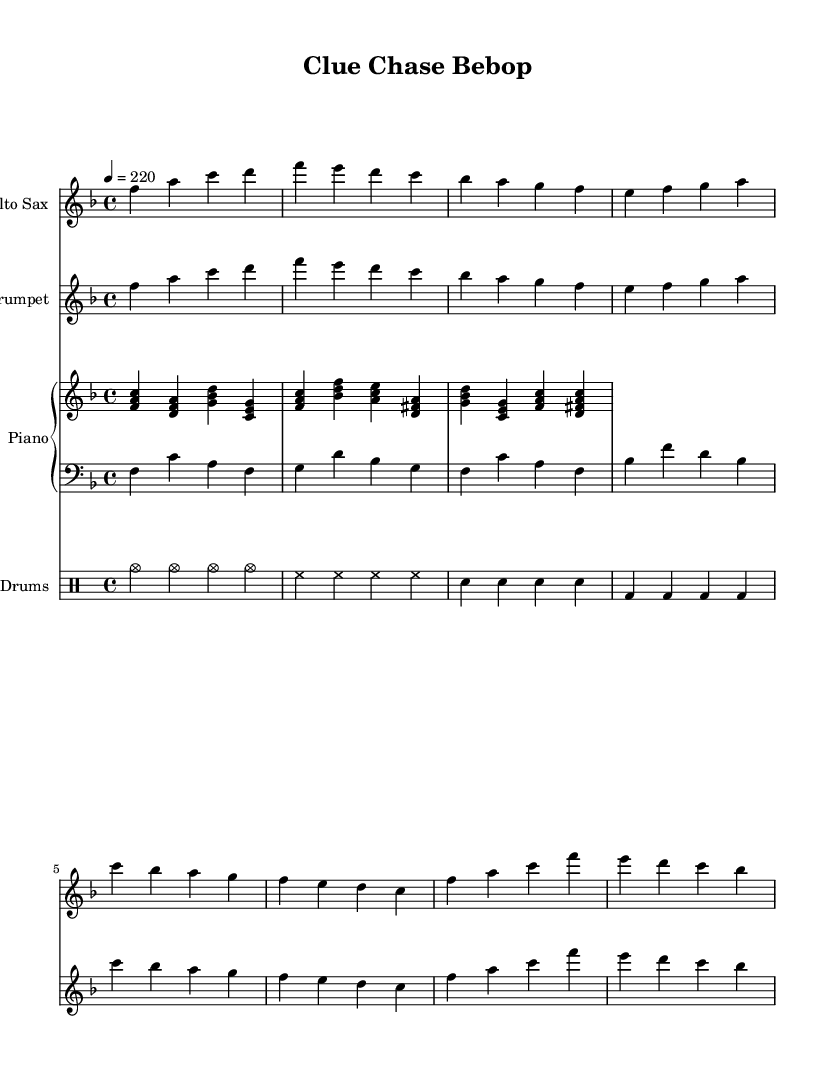What is the key signature of this music? The key signature indicates F major, which has one flat (B flat). This is visible at the beginning of the sheet music where the key signature is marked.
Answer: F major What is the time signature of this music? The time signature shown at the beginning of the sheet music is 4/4, which means there are four beats in a measure and the quarter note gets one beat. This can be confirmed by locating the time signature indicated at the start of the score.
Answer: 4/4 What is the tempo marking for this piece? The tempo marking in the sheet music indicates a tempo of 220 beats per minute, which is located under the global section at the beginning of the score.
Answer: 220 How many measures are in the sheet music? By counting the measures in every staff, the total number can be obtained. There are a total of 8 measures per staff, and there are four staves (Alto Sax, Trumpet, Piano, Drums), giving us a total of 32 measures.
Answer: 32 What is the primary chord used in the piano part? The primary chord in the piano part is the F major chord, consisting of the notes F, A, and C, which is evident from the initial bars of the piano staff.
Answer: F major What type of jazz is reflected in this piece? This piece is classified as bebop, known for its up-tempo and complex chord progressions, which are evident in the rapid note sequences and syncopated rhythms present in the melody and harmony.
Answer: Bebop How is the rhythm characterized in this music? The rhythm is characterized by a fast-paced and syncopated structure, typical of bebop, reflecting the excitement and thrill of investigating new clues. This can be inferred from the use of swung eighth notes and varied accents throughout the parts.
Answer: Syncopated 